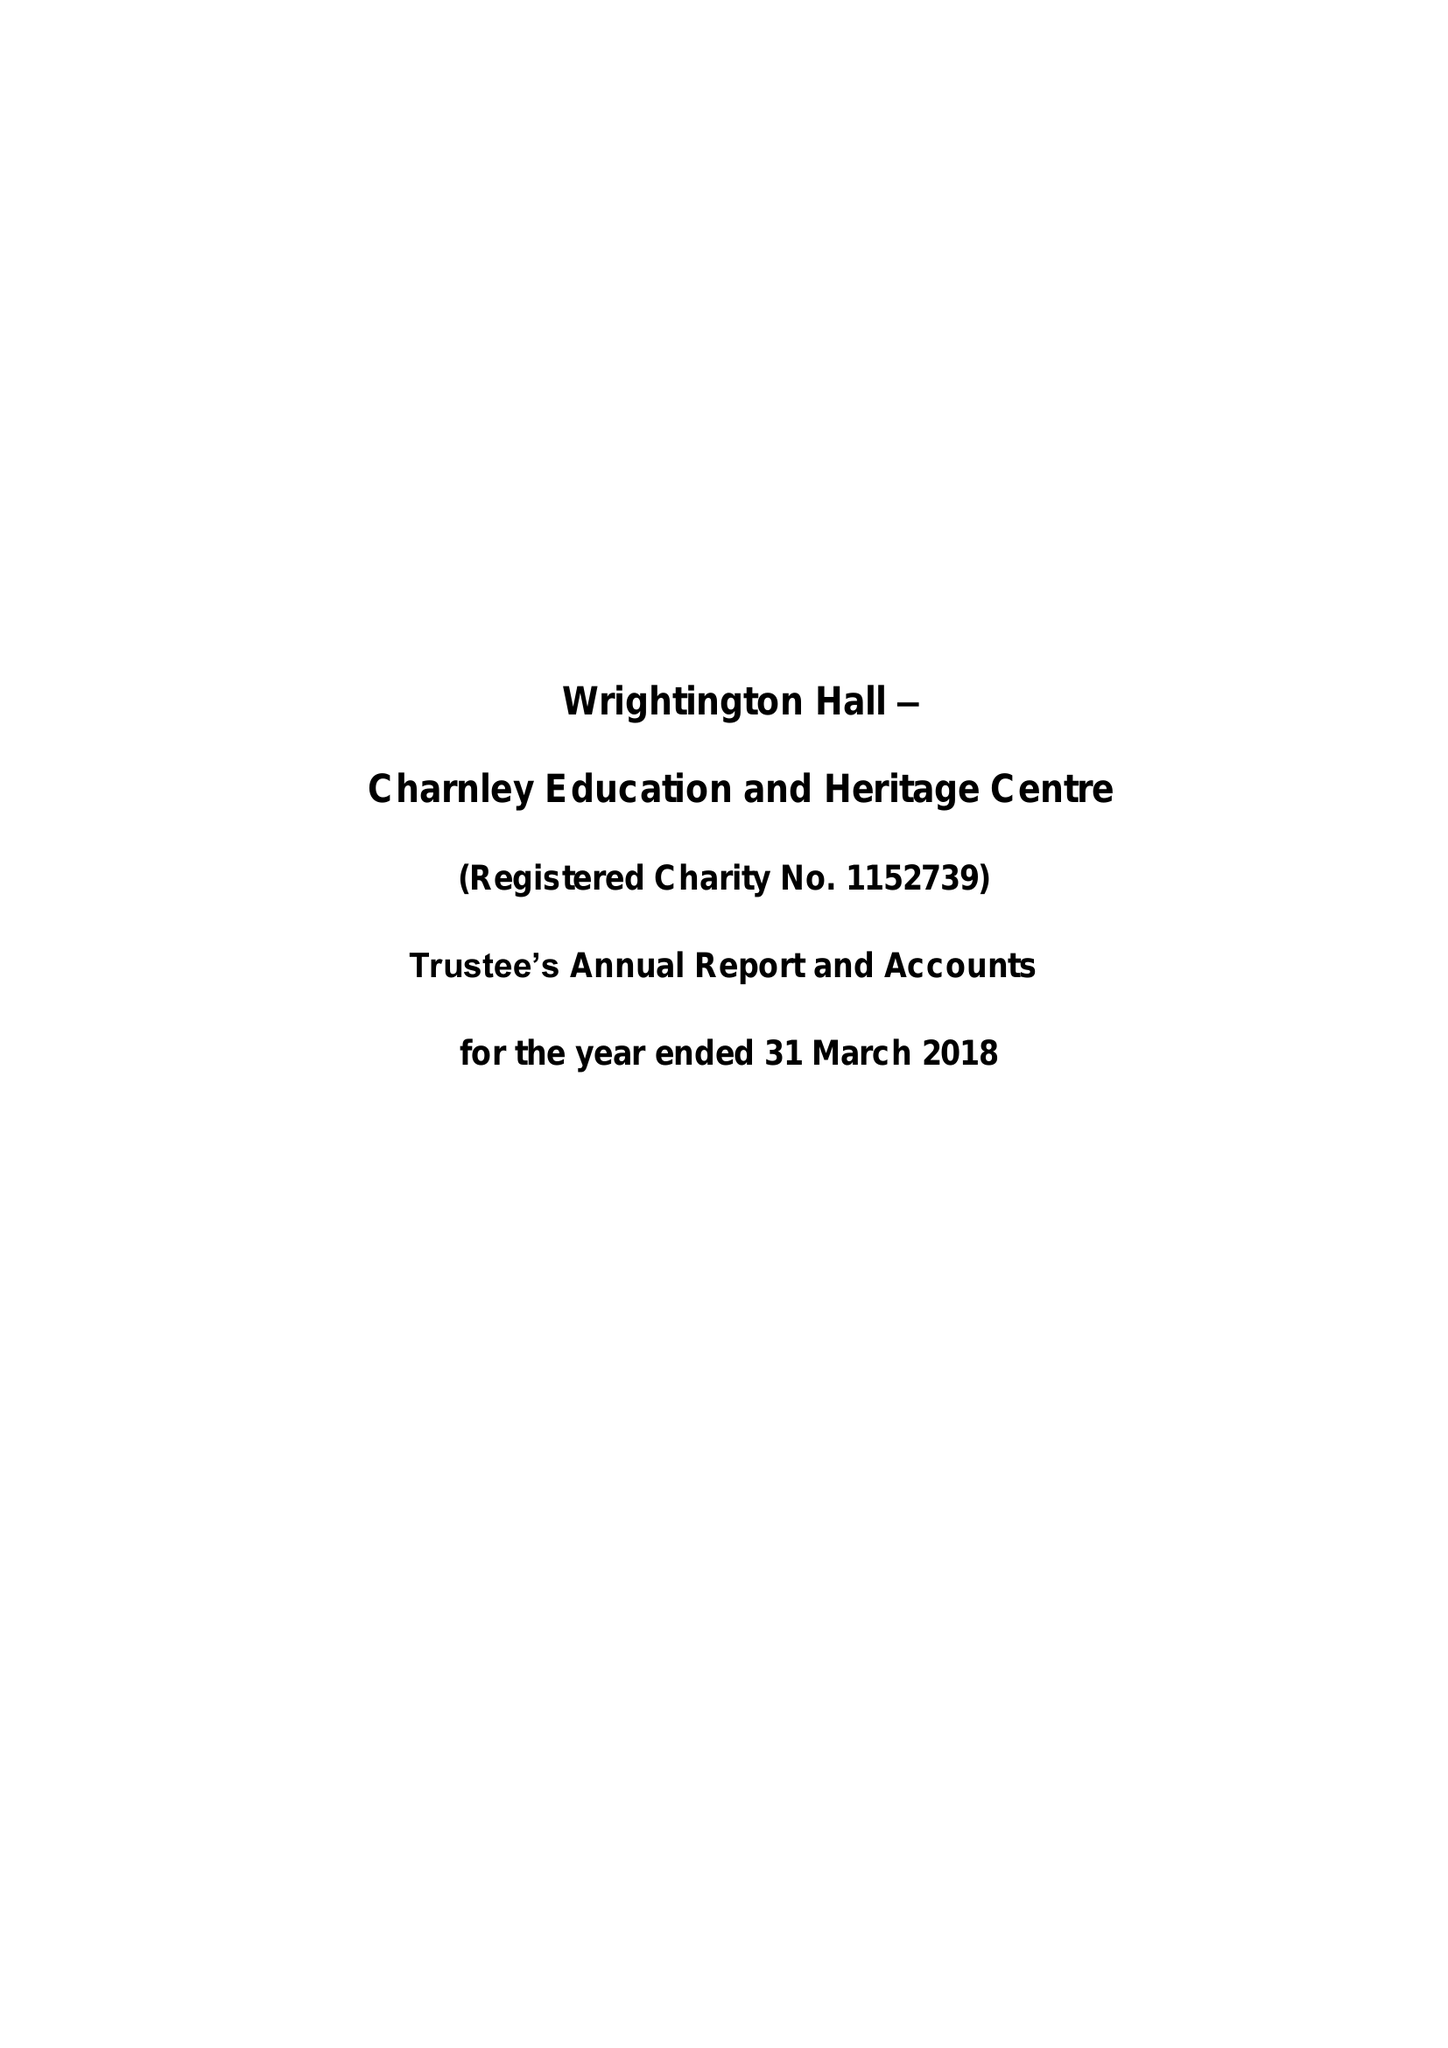What is the value for the spending_annually_in_british_pounds?
Answer the question using a single word or phrase. None 